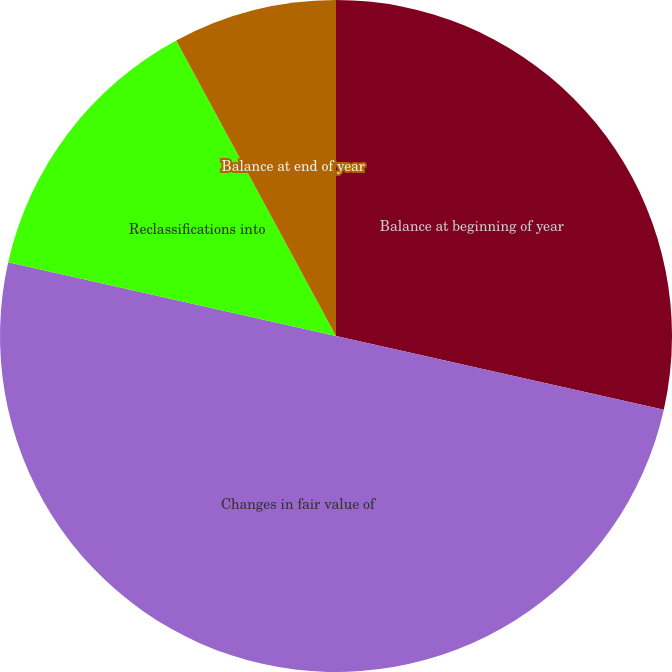Convert chart to OTSL. <chart><loc_0><loc_0><loc_500><loc_500><pie_chart><fcel>Balance at beginning of year<fcel>Changes in fair value of<fcel>Reclassifications into<fcel>Balance at end of year<nl><fcel>28.52%<fcel>50.0%<fcel>13.59%<fcel>7.89%<nl></chart> 